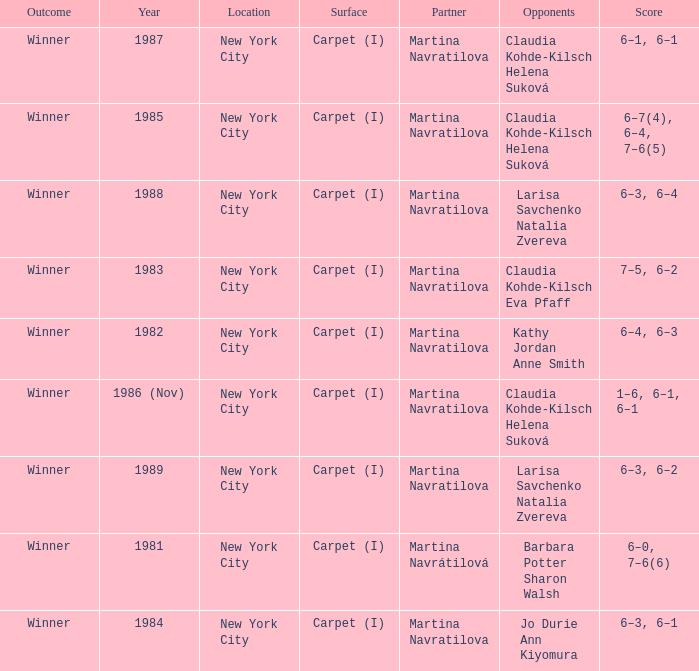How many locations hosted Claudia Kohde-Kilsch Eva Pfaff? 1.0. 